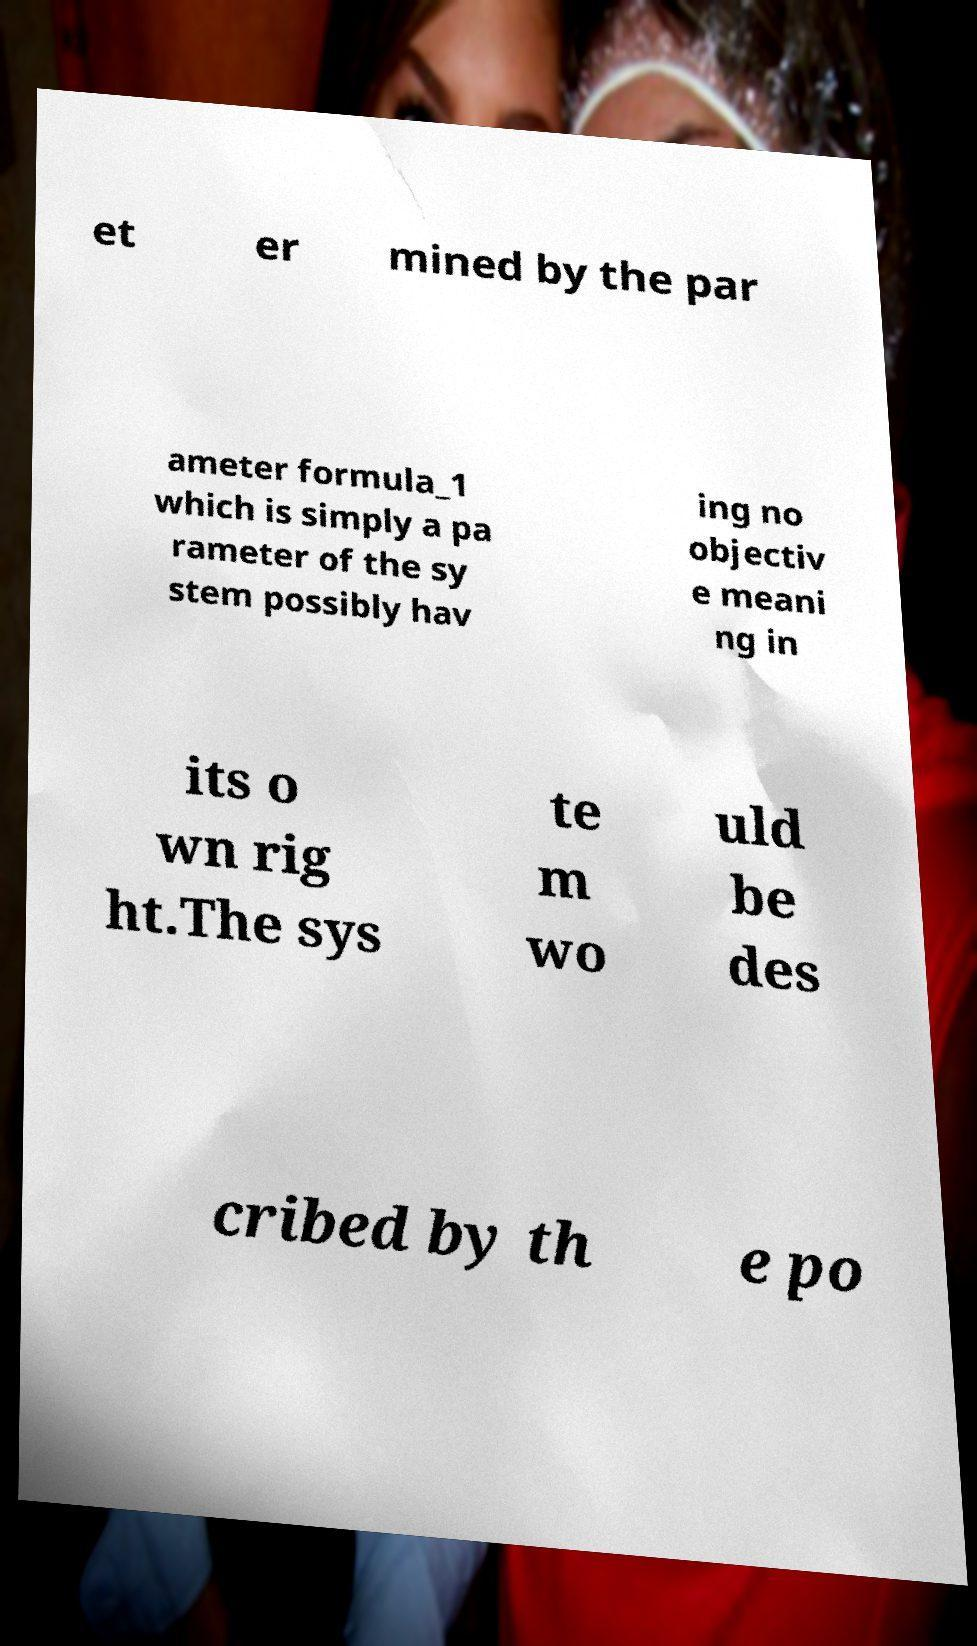Can you accurately transcribe the text from the provided image for me? et er mined by the par ameter formula_1 which is simply a pa rameter of the sy stem possibly hav ing no objectiv e meani ng in its o wn rig ht.The sys te m wo uld be des cribed by th e po 